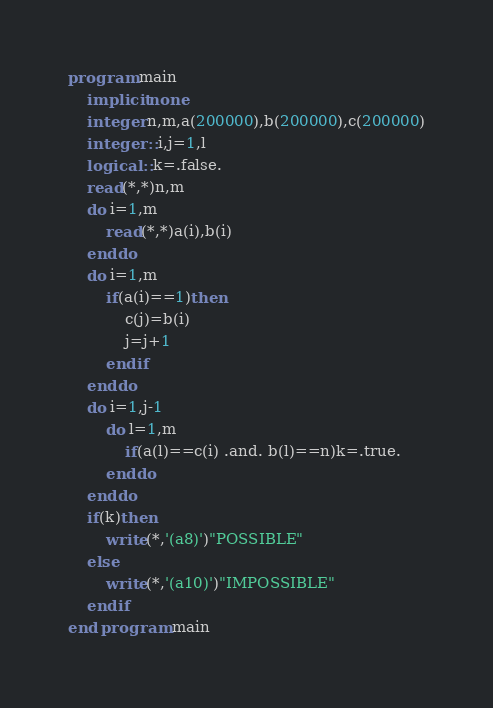Convert code to text. <code><loc_0><loc_0><loc_500><loc_500><_FORTRAN_>program main
	implicit none
	integer n,m,a(200000),b(200000),c(200000)
	integer ::i,j=1,l
	logical ::k=.false.
	read(*,*)n,m
	do i=1,m
		read(*,*)a(i),b(i)
	enddo
	do i=1,m
		if(a(i)==1)then
			c(j)=b(i)
			j=j+1
		endif
	enddo
	do i=1,j-1
		do l=1,m
			if(a(l)==c(i) .and. b(l)==n)k=.true.
		enddo
	enddo
	if(k)then
		write(*,'(a8)')"POSSIBLE"
	else
		write(*,'(a10)')"IMPOSSIBLE"
	endif
end program main
</code> 